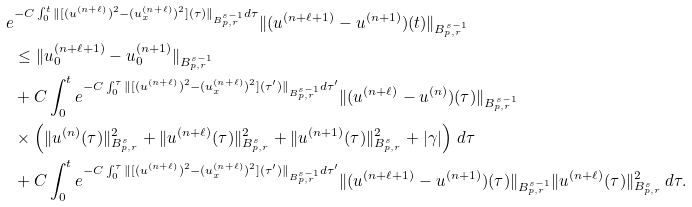<formula> <loc_0><loc_0><loc_500><loc_500>e & ^ { - C \int _ { 0 } ^ { t } \| [ ( u ^ { ( n + \ell ) } ) ^ { 2 } - ( u ^ { ( n + \ell ) } _ { x } ) ^ { 2 } ] ( \tau ) \| _ { B ^ { s - 1 } _ { p , r } } d \tau } \| ( u ^ { ( n + \ell + 1 ) } - u ^ { ( n + 1 ) } ) ( t ) \| _ { B ^ { s - 1 } _ { p , r } } \\ & \leq \| u _ { 0 } ^ { ( n + \ell + 1 ) } - u _ { 0 } ^ { ( n + 1 ) } \| _ { B ^ { s - 1 } _ { p , r } } \\ & + C \int _ { 0 } ^ { t } e ^ { - C \int _ { 0 } ^ { \tau } \| [ ( u ^ { ( n + \ell ) } ) ^ { 2 } - ( u ^ { ( n + \ell ) } _ { x } ) ^ { 2 } ] ( \tau ^ { \prime } ) \| _ { B ^ { s - 1 } _ { p , r } } d \tau ^ { \prime } } \| ( u ^ { ( n + \ell ) } - u ^ { ( n ) } ) ( \tau ) \| _ { B ^ { s - 1 } _ { p , r } } \\ & \times \left ( \| u ^ { ( n ) } ( \tau ) \| ^ { 2 } _ { B ^ { s } _ { p , r } } + \| u ^ { ( n + \ell ) } ( \tau ) \| ^ { 2 } _ { B ^ { s } _ { p , r } } + \| u ^ { ( n + 1 ) } ( \tau ) \| ^ { 2 } _ { B ^ { s } _ { p , r } } + | \gamma | \right ) \, d \tau \\ & + C \int _ { 0 } ^ { t } e ^ { - C \int _ { 0 } ^ { \tau } \| [ ( u ^ { ( n + \ell ) } ) ^ { 2 } - ( u ^ { ( n + \ell ) } _ { x } ) ^ { 2 } ] ( \tau ^ { \prime } ) \| _ { B ^ { s - 1 } _ { p , r } } d \tau ^ { \prime } } \| ( u ^ { ( n + \ell + 1 ) } - u ^ { ( n + 1 ) } ) ( \tau ) \| _ { B ^ { s - 1 } _ { p , r } } \| u ^ { ( n + \ell ) } ( \tau ) \| ^ { 2 } _ { B ^ { s } _ { p , r } } \, d \tau .</formula> 